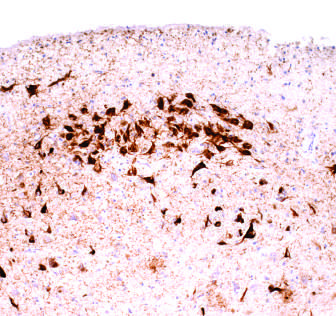re lobular carcinomas stained with an antibody specific for tau?
Answer the question using a single word or phrase. No 